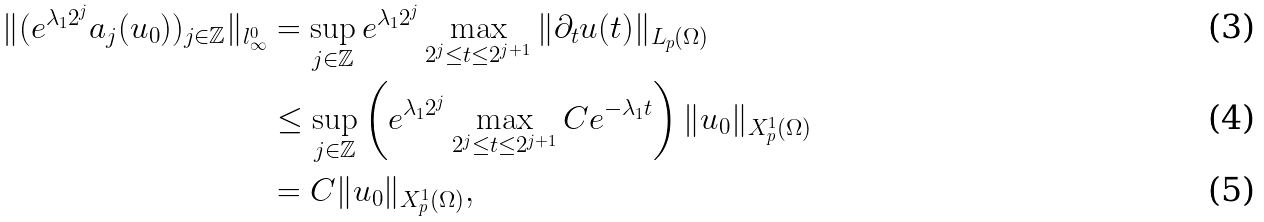<formula> <loc_0><loc_0><loc_500><loc_500>\| ( e ^ { \lambda _ { 1 } 2 ^ { j } } a _ { j } ( u _ { 0 } ) ) _ { j \in \mathbb { Z } } \| _ { l ^ { 0 } _ { \infty } } & = \sup _ { j \in \mathbb { Z } } e ^ { \lambda _ { 1 } 2 ^ { j } } \max _ { 2 ^ { j } \leq t \leq 2 ^ { j + 1 } } \| \partial _ { t } u ( t ) \| _ { L _ { p } ( \Omega ) } \\ & \leq \sup _ { j \in \mathbb { Z } } \left ( e ^ { \lambda _ { 1 } 2 ^ { j } } \max _ { 2 ^ { j } \leq t \leq 2 ^ { j + 1 } } C e ^ { - \lambda _ { 1 } t } \right ) \| u _ { 0 } \| _ { X ^ { 1 } _ { p } ( \Omega ) } \\ & = C \| u _ { 0 } \| _ { X ^ { 1 } _ { p } ( \Omega ) } ,</formula> 